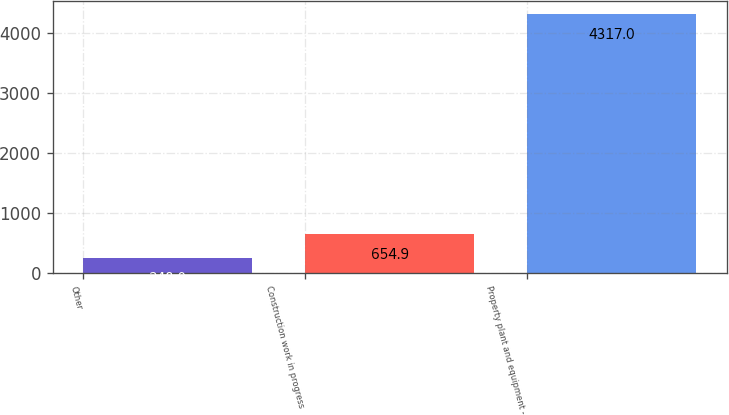Convert chart. <chart><loc_0><loc_0><loc_500><loc_500><bar_chart><fcel>Other<fcel>Construction work in progress<fcel>Property plant and equipment -<nl><fcel>248<fcel>654.9<fcel>4317<nl></chart> 